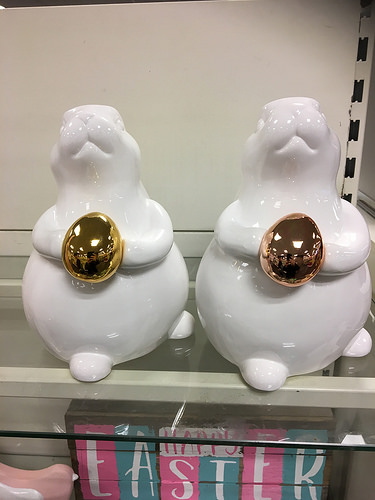<image>
Is there a egg in front of the rabbit? Yes. The egg is positioned in front of the rabbit, appearing closer to the camera viewpoint. 